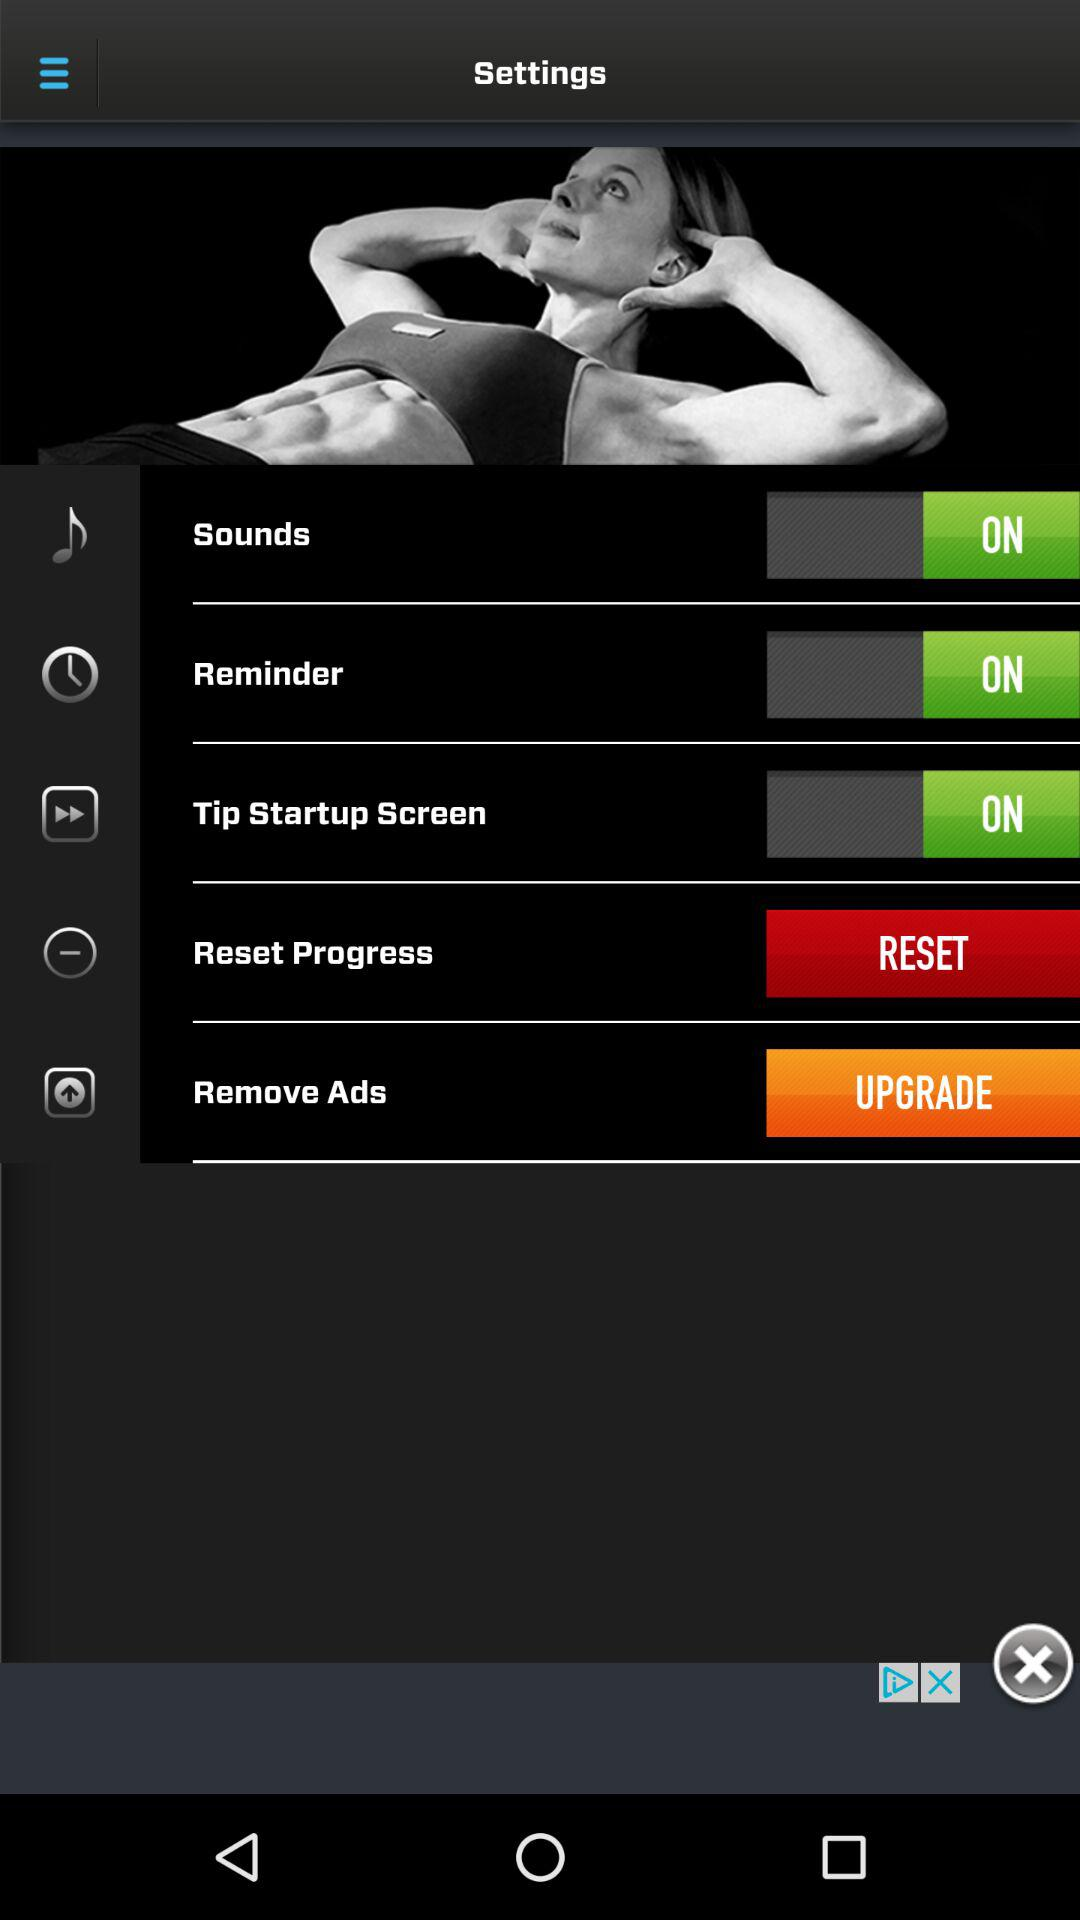How many switches are in the settings menu?
Answer the question using a single word or phrase. 3 